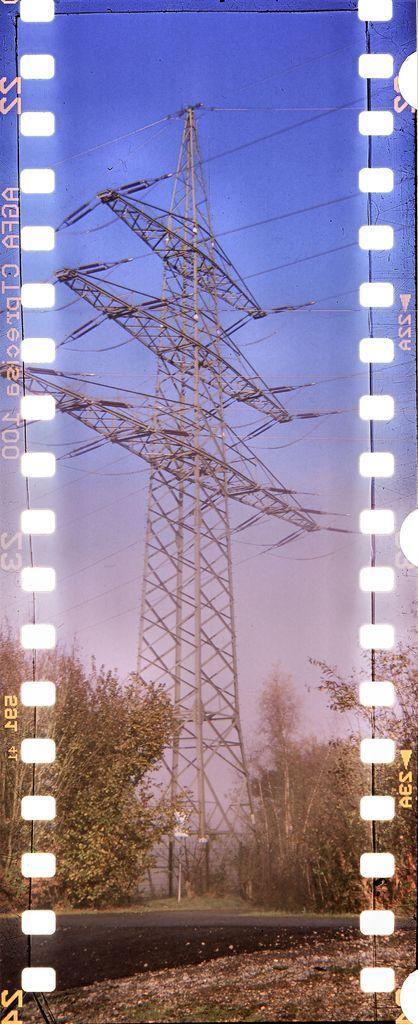Please provide a concise description of this image. This is an edited picture. I can see a cellphone tower, there are cables, there are trees, and in the background there is the sky. There are words and numbers on the image. 